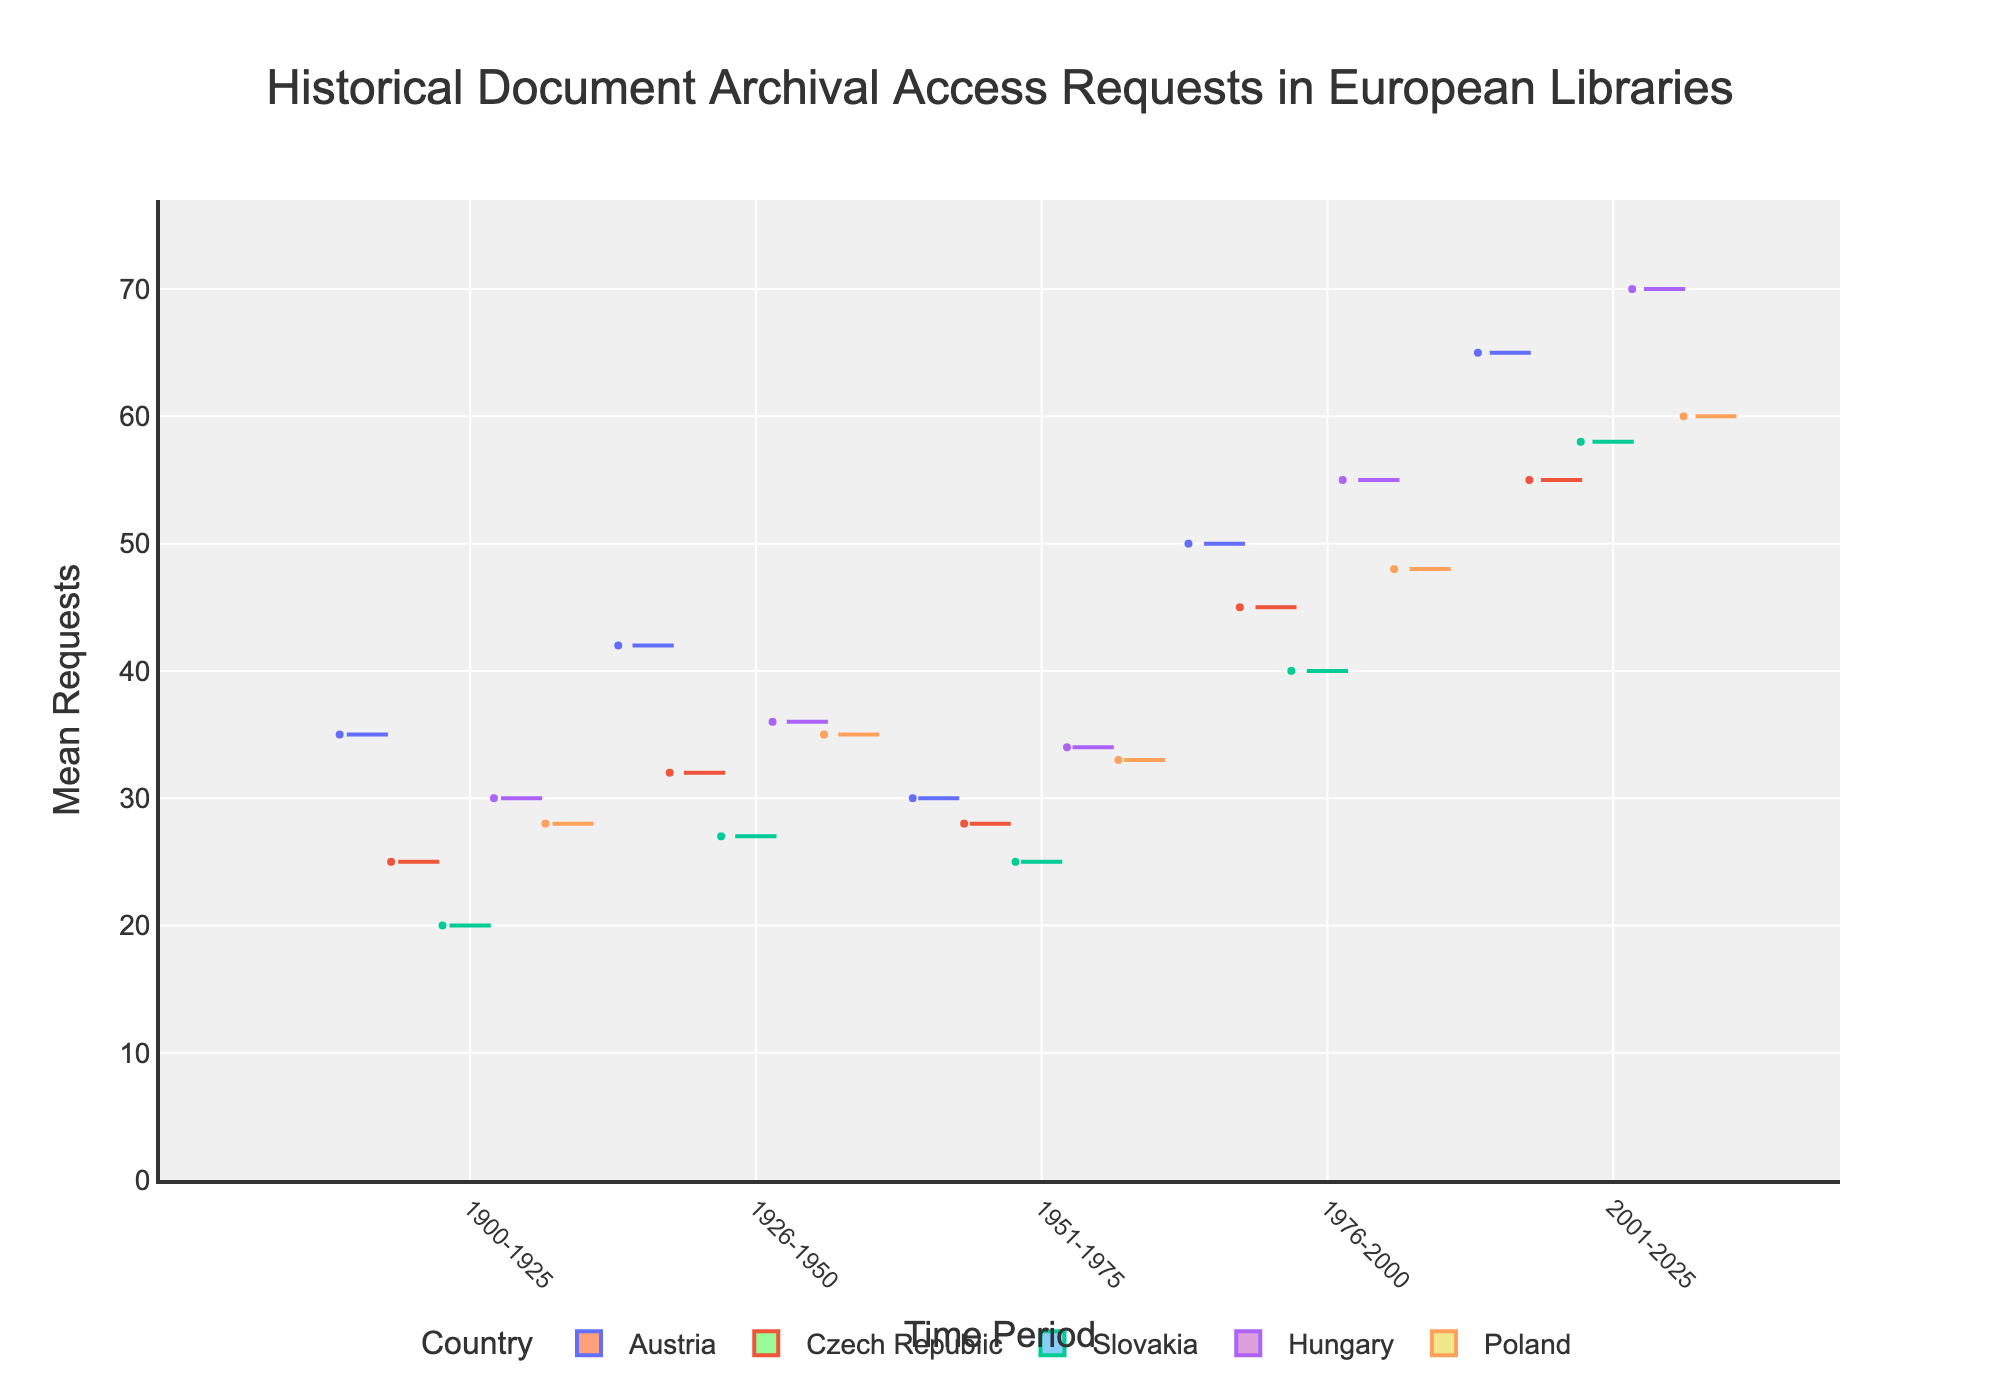Which country has the highest mean requests in the time period 2001-2025? By examining the plot, locate the box representing each country for the time period 2001-2025. Identify which box has the highest position on the y-axis. This represents the highest mean requests.
Answer: Hungary How does the variability of requests in Austria compare between 1900-1925 and 2001-2025? Look at the spread of the boxes for Austria in these two time periods. The spread is indicative of variability. A wider box or longer whiskers indicate higher variability.
Answer: More variable in 2001-2025 Which country shows the smallest difference in mean requests between 1900-1925 and 1951-1975 for scholarly access? Compare the y-axis positions of the boxes representing these periods for each country. Calculate the differences: for Austria it's (35-30), for the Czech Republic it's (25-28), for Slovakia it's (20-25). The smallest difference indicates the country.
Answer: Slovakia What is the general trend in mean requests in Slovakia from 1900 to 2025? Assess the sequential order of the boxes for Slovakia across the time periods. Observe if the boxes move higher or lower on the y-axis over time.
Answer: Increasing trend Which country had the highest variability in requests in the period 1976-2000? Compare the spreads of the boxes in the period 1976-2000 for all countries. The country with the largest spread or widest interquartile range has the highest variability.
Answer: Austria How do the requests in the most recent period (2001-2025) compare between scholarly and research access types? Find the boxes representing 2001-2025 for each access type. Notice the y-axis levels of the boxes to identify which are higher or lower.
Answer: Scholarly access has lower mean requests than research access What is the average number of mean requests in Slovakia over all time periods? Sum mean requests for Slovakia across all periods: 20 + 27 + 25 + 40 + 58 = 170. The average is then 170 divided by the number of time periods (5).
Answer: 34 In which period did the Czech Republic see the most significant increase in mean requests compared to its previous period? Calculate the differences in mean requests between consecutive periods for the Czech Republic: (32-25), (28-32), (45-28), (55-45). Identify the largest increase.
Answer: 1976-2000 Who had consistently higher mean requests over all periods, Hungary or Poland? Compare the position of boxes for Hungary and Poland across all periods. Identify which country generally has higher positions on the y-axis.
Answer: Hungary 